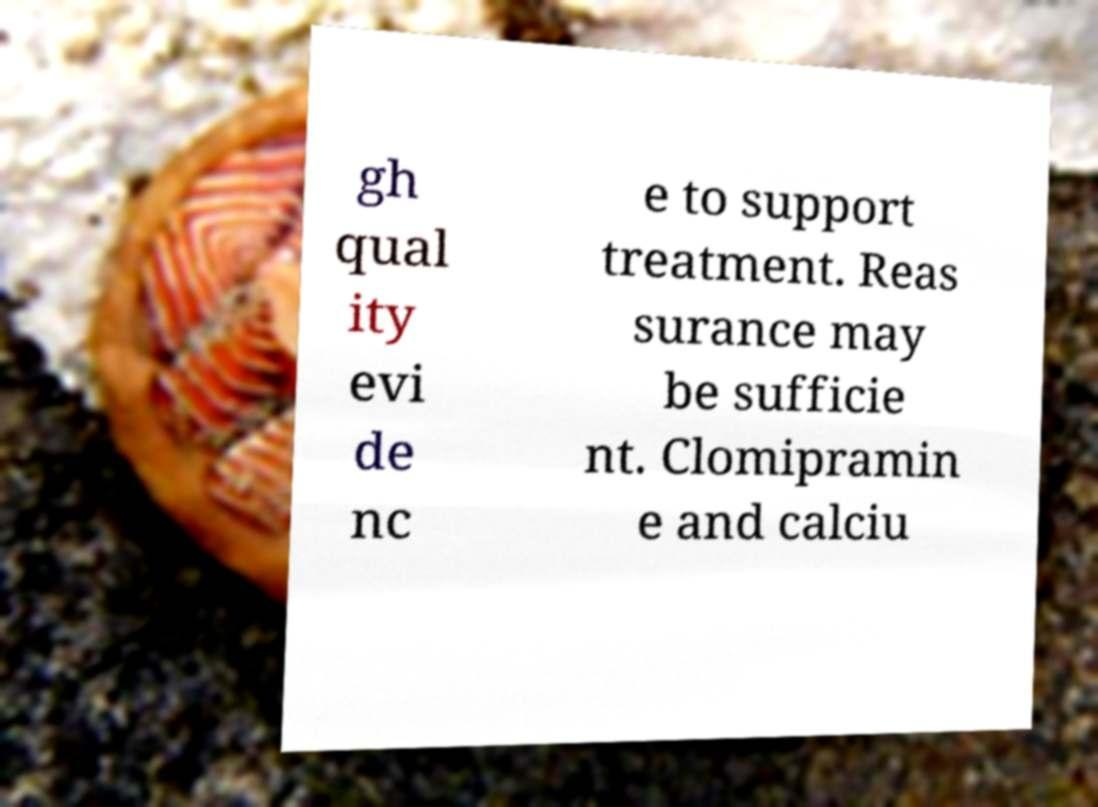Please read and relay the text visible in this image. What does it say? gh qual ity evi de nc e to support treatment. Reas surance may be sufficie nt. Clomipramin e and calciu 